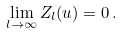Convert formula to latex. <formula><loc_0><loc_0><loc_500><loc_500>\lim _ { l \to \infty } Z _ { l } ( u ) = 0 \, .</formula> 